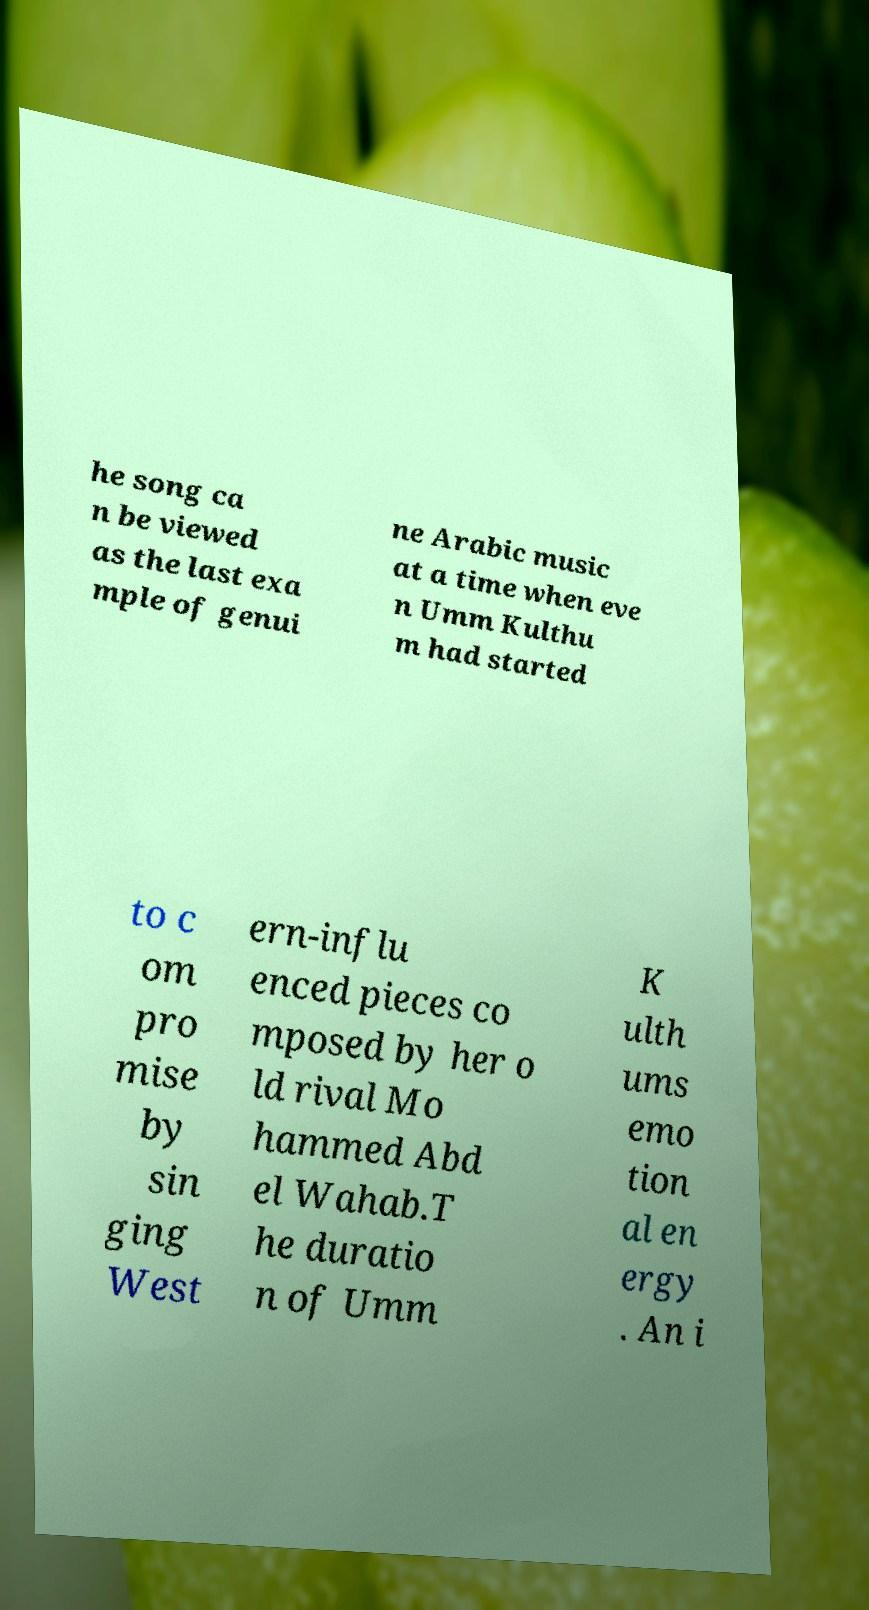Could you extract and type out the text from this image? he song ca n be viewed as the last exa mple of genui ne Arabic music at a time when eve n Umm Kulthu m had started to c om pro mise by sin ging West ern-influ enced pieces co mposed by her o ld rival Mo hammed Abd el Wahab.T he duratio n of Umm K ulth ums emo tion al en ergy . An i 